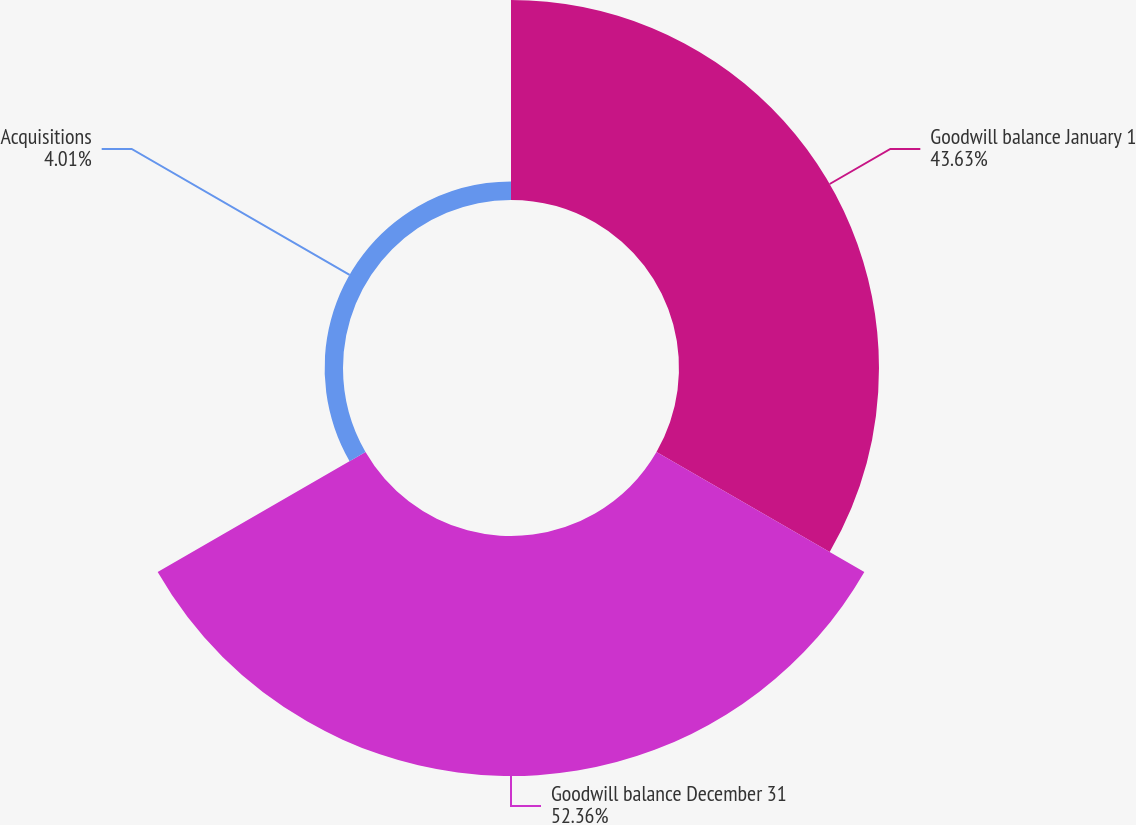<chart> <loc_0><loc_0><loc_500><loc_500><pie_chart><fcel>Goodwill balance January 1<fcel>Goodwill balance December 31<fcel>Acquisitions<nl><fcel>43.63%<fcel>52.36%<fcel>4.01%<nl></chart> 